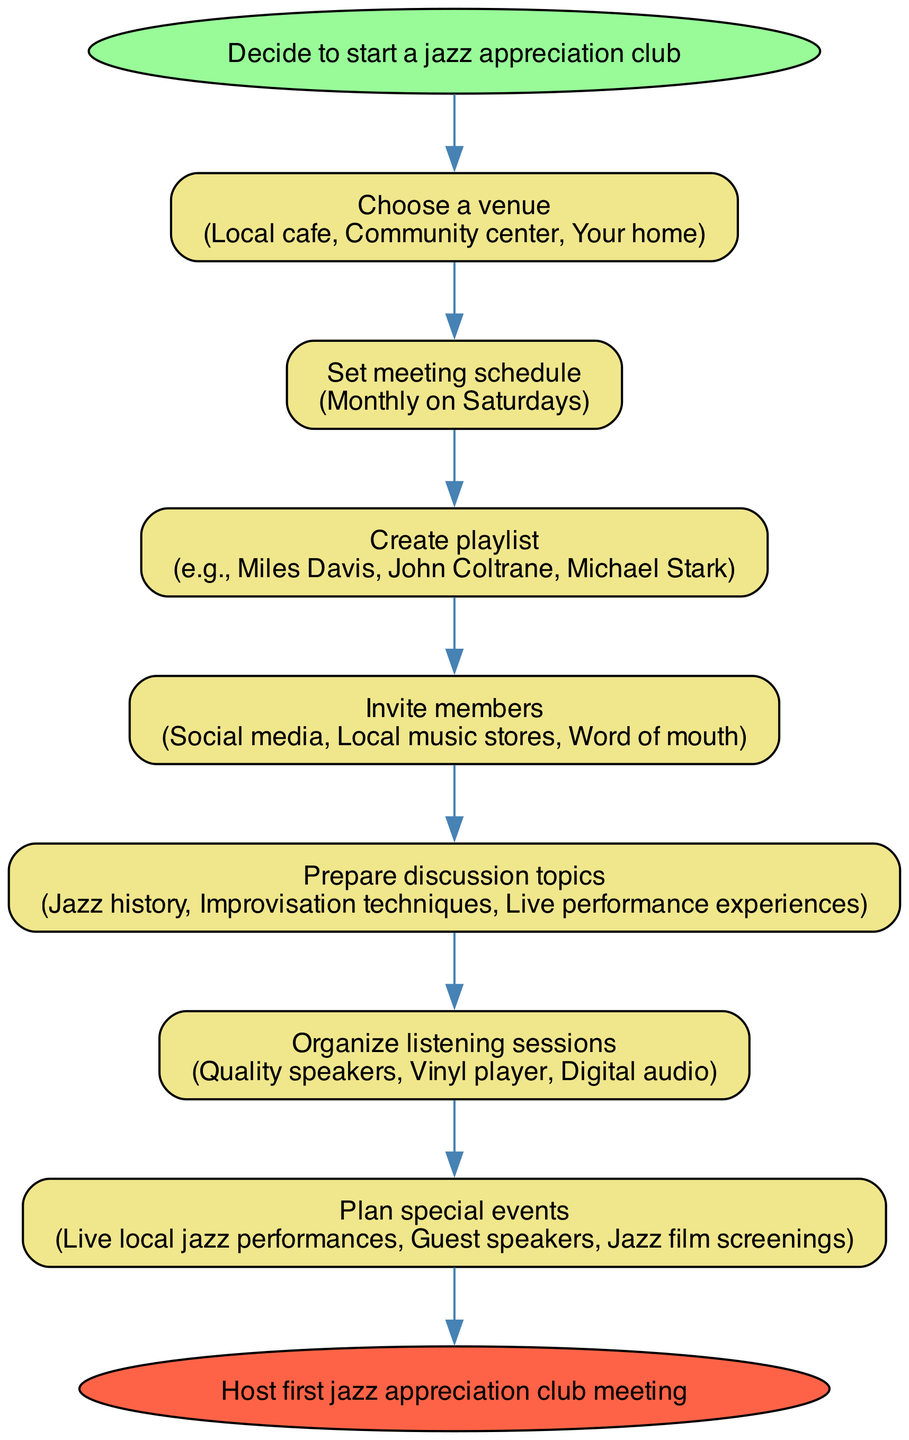What is the first step to organize a jazz appreciation club? The diagram begins with the node labeled "Decide to start a jazz appreciation club," indicating this is the initial action required before proceeding with any other steps.
Answer: Decide to start a jazz appreciation club How many steps are there in total to organize the club? The diagram lists the steps that need to be taken to organize the club, which includes 7 steps in total plus the start and end nodes. Counting only the detailed steps gives us 7.
Answer: 7 What venue options are suggested for the club? The relevant node provides several options for venues, namely "Local cafe," "Community center," and "Your home." Each option is presented in the same node, where those interested can choose any of these as a gathering place.
Answer: Local cafe, Community center, Your home What is the frequency of the meetings? The step labeled "Set meeting schedule" details that the meetings should be held "Monthly on Saturdays," indicating the regularity and timing for the gatherings.
Answer: Monthly on Saturdays Which musicians are included in the create playlist step? In the "Create playlist" node, specific examples of musicians are provided: "Miles Davis," "John Coltrane," and "Michael Stark." This suggests that these artists should be featured in the playlists curated for the meetings.
Answer: Miles Davis, John Coltrane, Michael Stark What methods are suggested for inviting members? The "Invite members" step outlines several methods, which include "Social media," "Local music stores," and "Word of mouth." These methods are specifically indicated for gathering members for the appreciation club.
Answer: Social media, Local music stores, Word of mouth What are some special event options listed in the diagram? The diagram under the "Plan special events" node lists three options: "Live local jazz performances," "Guest speakers," and "Jazz film screenings." These options provide varied entertainment for the club members.
Answer: Live local jazz performances, Guest speakers, Jazz film screenings Which equipment is recommended for organizing listening sessions? The "Organize listening sessions" step specifies the required equipment, mentioned as "Quality speakers," "Vinyl player," and "Digital audio," indicating the tools needed for an effective listening experience.
Answer: Quality speakers, Vinyl player, Digital audio What is the final outcome after completing all steps? The end node of the diagram states that the final goal is to "Host first jazz appreciation club meeting," summing up the intended result of all preceding activities.
Answer: Host first jazz appreciation club meeting 